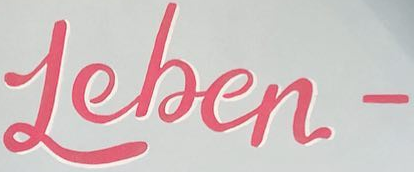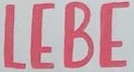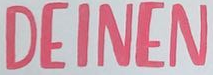What text is displayed in these images sequentially, separated by a semicolon? Leben-; LEBE; DEINEN 